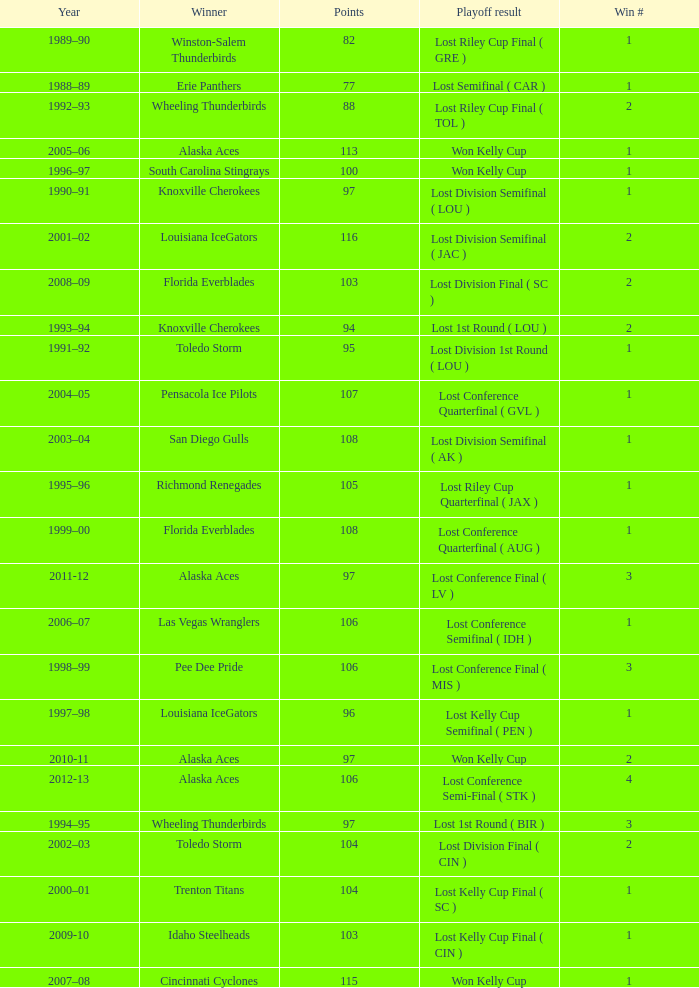What is Winner, when Win # is greater than 1, and when Points is less than 94? Wheeling Thunderbirds. 